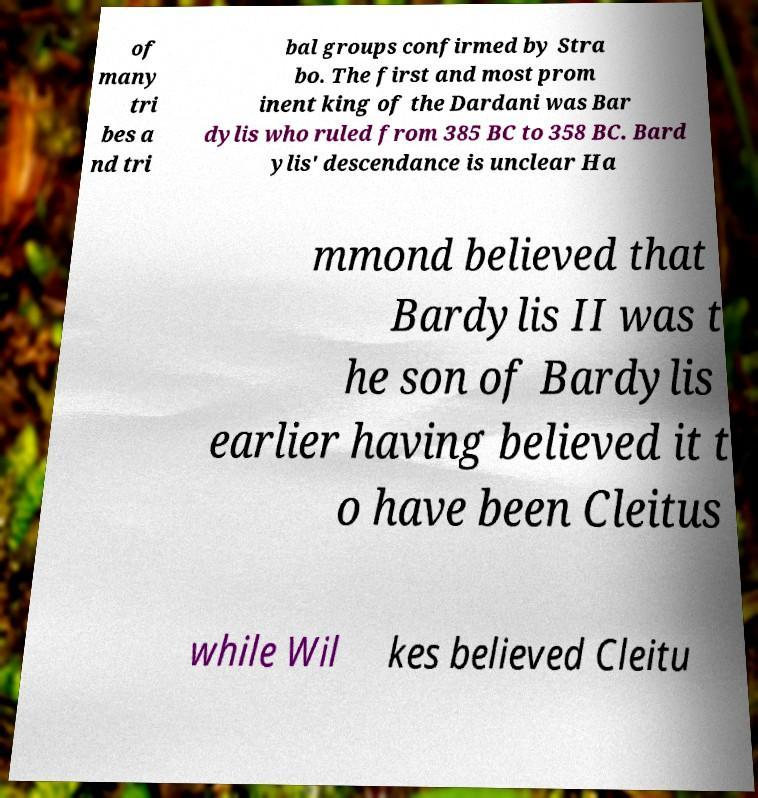Please identify and transcribe the text found in this image. of many tri bes a nd tri bal groups confirmed by Stra bo. The first and most prom inent king of the Dardani was Bar dylis who ruled from 385 BC to 358 BC. Bard ylis' descendance is unclear Ha mmond believed that Bardylis II was t he son of Bardylis earlier having believed it t o have been Cleitus while Wil kes believed Cleitu 